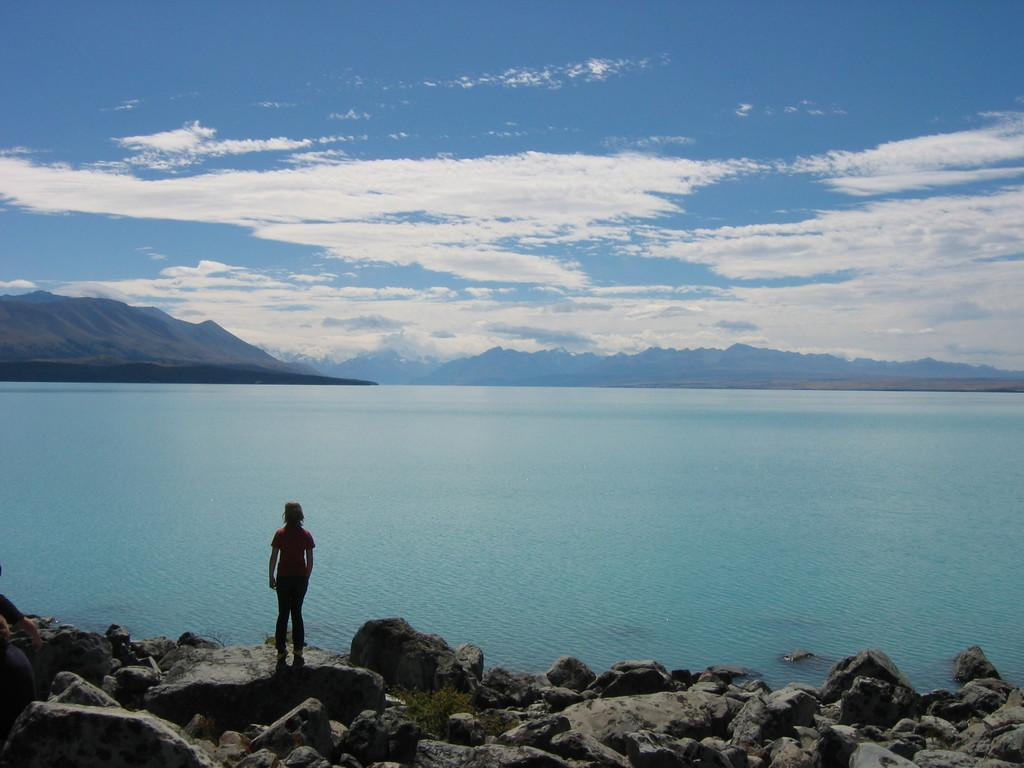What is the person in the image standing on? The person is standing on a rock in the image. What is in front of the person? There is water in front of the person. What can be seen in the distance behind the person? Mountains are visible in the background of the image. What else can be seen in the background of the image? The sky is visible in the background of the image. What type of string is being used to create the art in the image? There is no art or string present in the image; it features a person standing on a rock with water, mountains, and the sky in the background. 